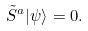<formula> <loc_0><loc_0><loc_500><loc_500>\tilde { S } ^ { a } | \psi \rangle = 0 .</formula> 